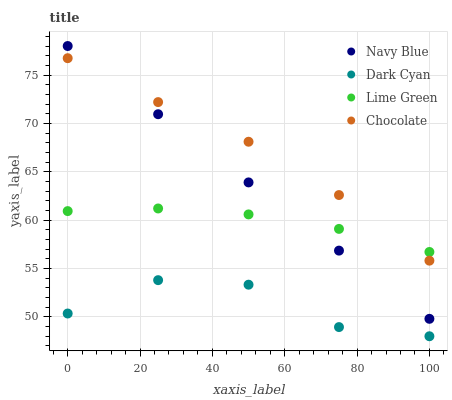Does Dark Cyan have the minimum area under the curve?
Answer yes or no. Yes. Does Chocolate have the maximum area under the curve?
Answer yes or no. Yes. Does Navy Blue have the minimum area under the curve?
Answer yes or no. No. Does Navy Blue have the maximum area under the curve?
Answer yes or no. No. Is Navy Blue the smoothest?
Answer yes or no. Yes. Is Dark Cyan the roughest?
Answer yes or no. Yes. Is Lime Green the smoothest?
Answer yes or no. No. Is Lime Green the roughest?
Answer yes or no. No. Does Dark Cyan have the lowest value?
Answer yes or no. Yes. Does Navy Blue have the lowest value?
Answer yes or no. No. Does Navy Blue have the highest value?
Answer yes or no. Yes. Does Lime Green have the highest value?
Answer yes or no. No. Is Dark Cyan less than Chocolate?
Answer yes or no. Yes. Is Navy Blue greater than Dark Cyan?
Answer yes or no. Yes. Does Navy Blue intersect Chocolate?
Answer yes or no. Yes. Is Navy Blue less than Chocolate?
Answer yes or no. No. Is Navy Blue greater than Chocolate?
Answer yes or no. No. Does Dark Cyan intersect Chocolate?
Answer yes or no. No. 